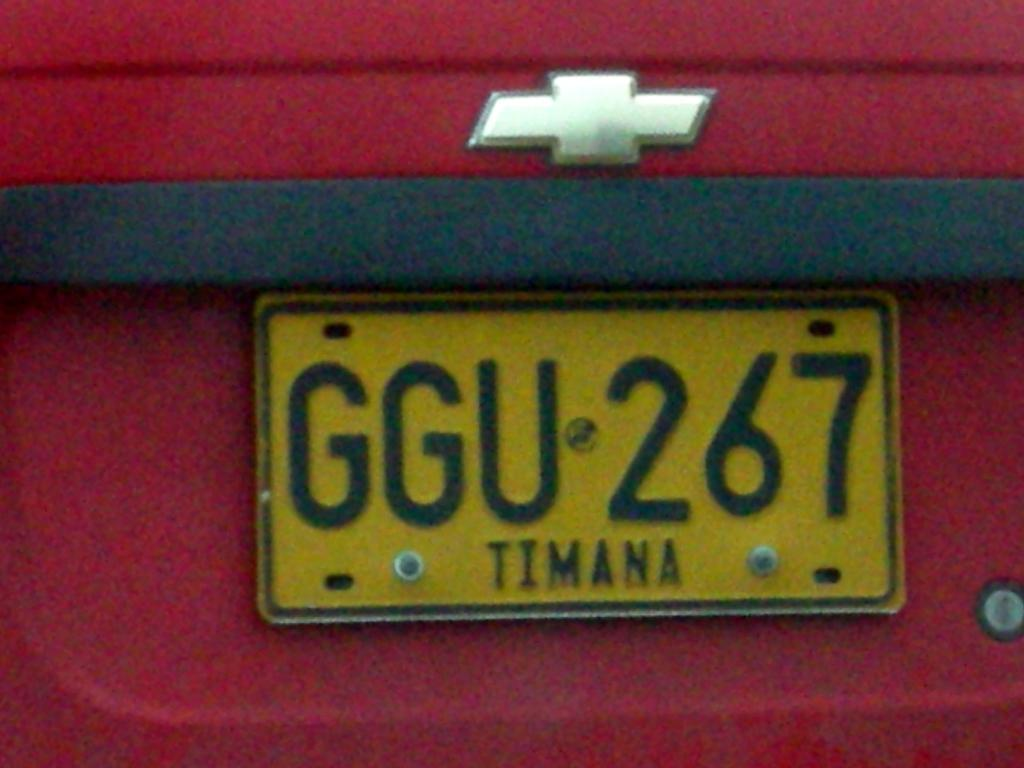<image>
Render a clear and concise summary of the photo. A red Chevrolet has a yellow license plate that says Timana. 